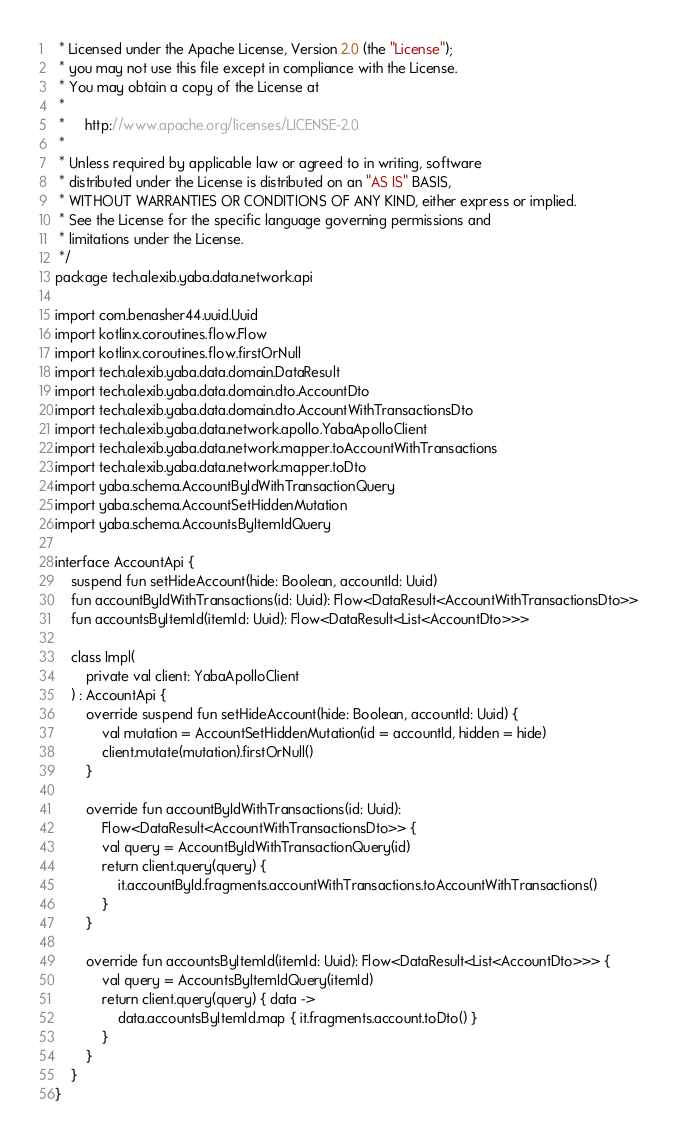<code> <loc_0><loc_0><loc_500><loc_500><_Kotlin_> * Licensed under the Apache License, Version 2.0 (the "License");
 * you may not use this file except in compliance with the License.
 * You may obtain a copy of the License at
 *
 *     http://www.apache.org/licenses/LICENSE-2.0
 *
 * Unless required by applicable law or agreed to in writing, software
 * distributed under the License is distributed on an "AS IS" BASIS,
 * WITHOUT WARRANTIES OR CONDITIONS OF ANY KIND, either express or implied.
 * See the License for the specific language governing permissions and
 * limitations under the License.
 */
package tech.alexib.yaba.data.network.api

import com.benasher44.uuid.Uuid
import kotlinx.coroutines.flow.Flow
import kotlinx.coroutines.flow.firstOrNull
import tech.alexib.yaba.data.domain.DataResult
import tech.alexib.yaba.data.domain.dto.AccountDto
import tech.alexib.yaba.data.domain.dto.AccountWithTransactionsDto
import tech.alexib.yaba.data.network.apollo.YabaApolloClient
import tech.alexib.yaba.data.network.mapper.toAccountWithTransactions
import tech.alexib.yaba.data.network.mapper.toDto
import yaba.schema.AccountByIdWithTransactionQuery
import yaba.schema.AccountSetHiddenMutation
import yaba.schema.AccountsByItemIdQuery

interface AccountApi {
    suspend fun setHideAccount(hide: Boolean, accountId: Uuid)
    fun accountByIdWithTransactions(id: Uuid): Flow<DataResult<AccountWithTransactionsDto>>
    fun accountsByItemId(itemId: Uuid): Flow<DataResult<List<AccountDto>>>

    class Impl(
        private val client: YabaApolloClient
    ) : AccountApi {
        override suspend fun setHideAccount(hide: Boolean, accountId: Uuid) {
            val mutation = AccountSetHiddenMutation(id = accountId, hidden = hide)
            client.mutate(mutation).firstOrNull()
        }

        override fun accountByIdWithTransactions(id: Uuid):
            Flow<DataResult<AccountWithTransactionsDto>> {
            val query = AccountByIdWithTransactionQuery(id)
            return client.query(query) {
                it.accountById.fragments.accountWithTransactions.toAccountWithTransactions()
            }
        }

        override fun accountsByItemId(itemId: Uuid): Flow<DataResult<List<AccountDto>>> {
            val query = AccountsByItemIdQuery(itemId)
            return client.query(query) { data ->
                data.accountsByItemId.map { it.fragments.account.toDto() }
            }
        }
    }
}
</code> 